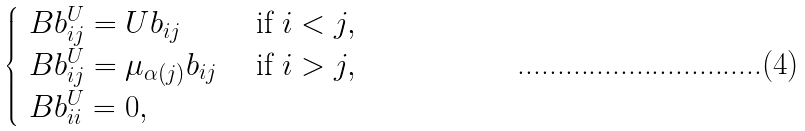Convert formula to latex. <formula><loc_0><loc_0><loc_500><loc_500>\begin{cases} \ B b _ { i j } ^ { U } = U b _ { i j } & \text { if } i < j , \\ \ B b _ { i j } ^ { U } = \mu _ { \alpha ( j ) } b _ { i j } & \text { if } i > j , \\ \ B b _ { i i } ^ { U } = 0 , \end{cases}</formula> 